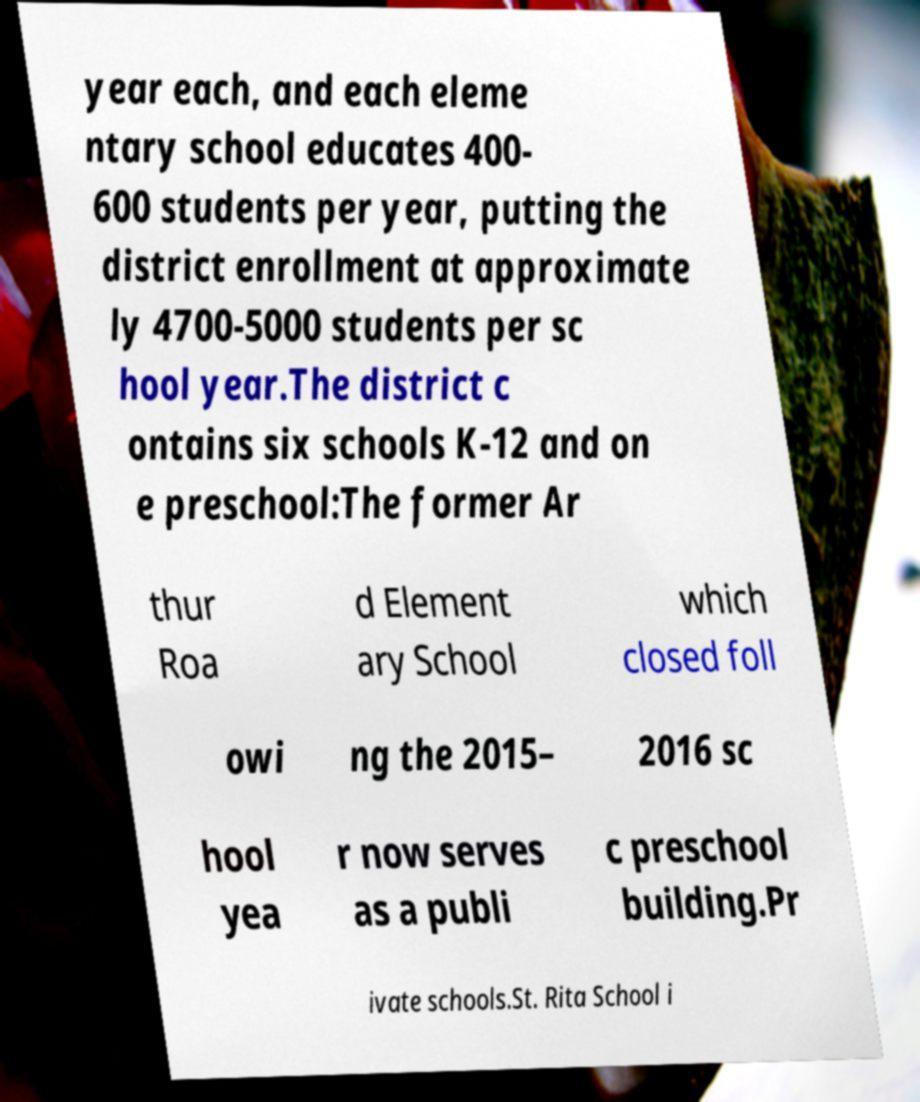Please read and relay the text visible in this image. What does it say? year each, and each eleme ntary school educates 400- 600 students per year, putting the district enrollment at approximate ly 4700-5000 students per sc hool year.The district c ontains six schools K-12 and on e preschool:The former Ar thur Roa d Element ary School which closed foll owi ng the 2015– 2016 sc hool yea r now serves as a publi c preschool building.Pr ivate schools.St. Rita School i 